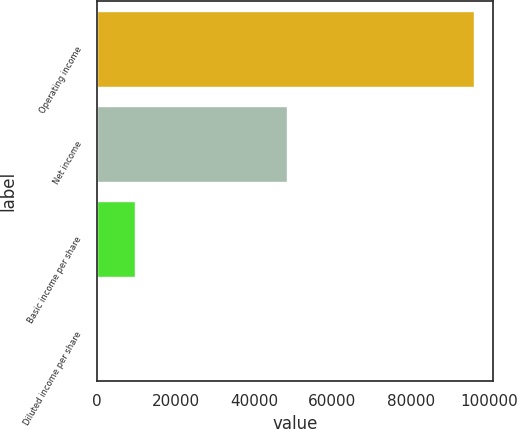Convert chart. <chart><loc_0><loc_0><loc_500><loc_500><bar_chart><fcel>Operating income<fcel>Net income<fcel>Basic income per share<fcel>Diluted income per share<nl><fcel>96183<fcel>48423<fcel>9618.71<fcel>0.46<nl></chart> 